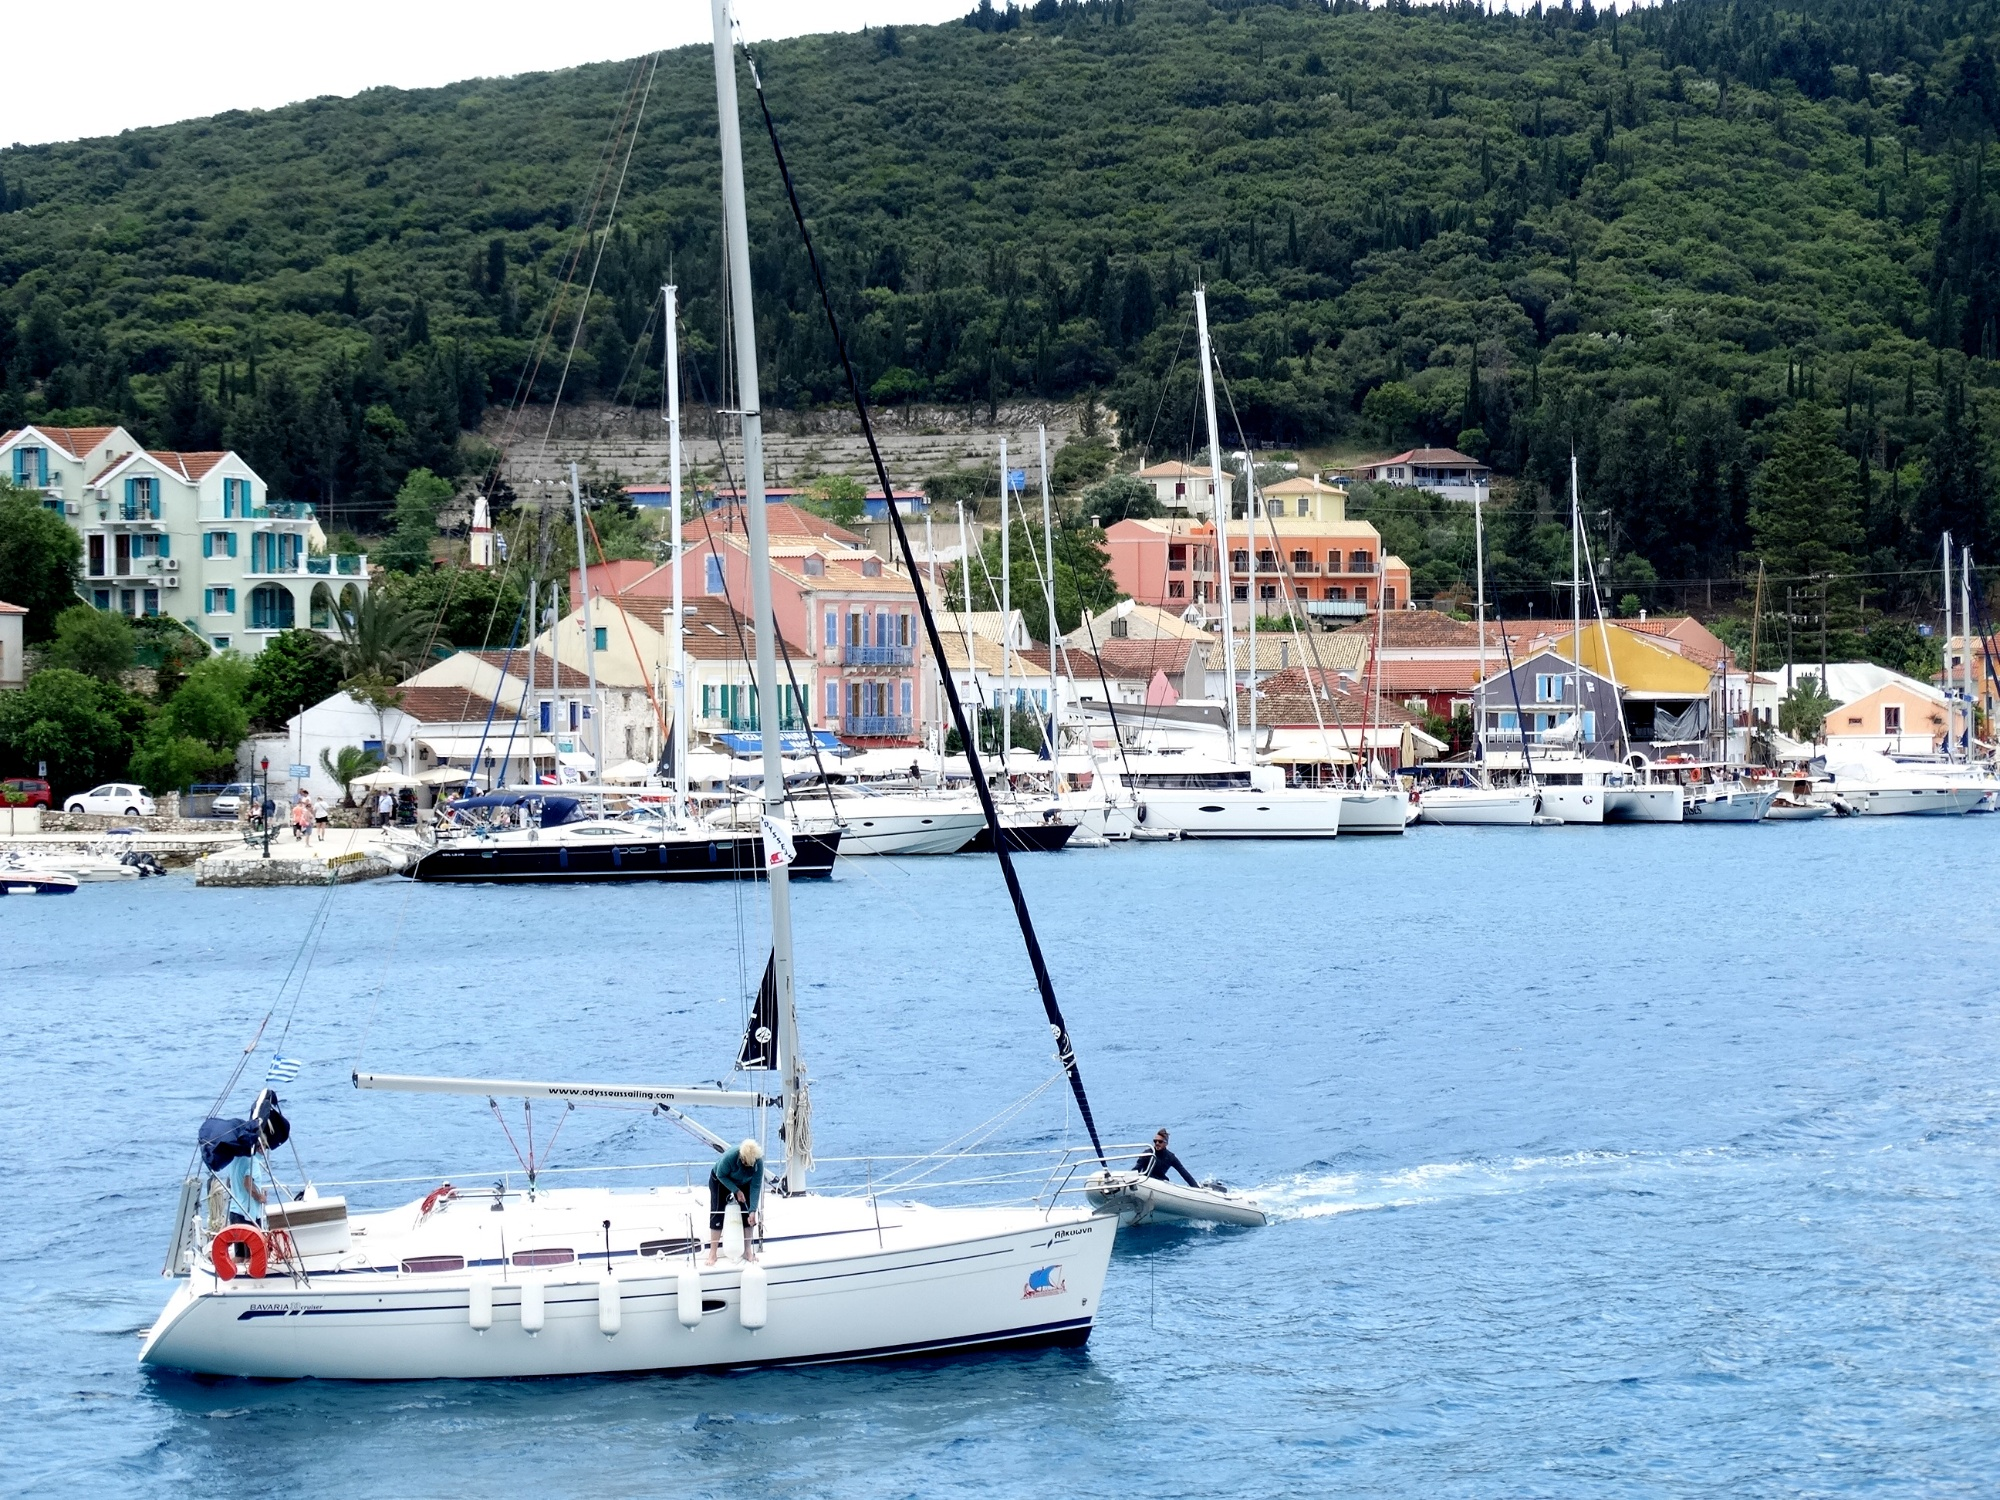What are some of the activities that might be happening in this town aside from sailing? In a bustling Mediterranean harbor town such as this, one might find a variety of activities. Locals and tourists alike could be enjoying waterfront dining at cafes and restaurants, exploring narrow cobblestone streets and local shops, or immersing themselves in cultural experiences at nearby historical sites and museums. The presence of hills also suggests possible hiking or nature walks with scenic views of the coastline. 